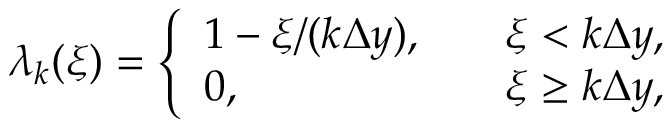Convert formula to latex. <formula><loc_0><loc_0><loc_500><loc_500>\lambda _ { k } ( \xi ) = \left \{ \begin{array} { l l } { 1 - \xi / ( k \Delta y ) , \quad } & { \xi < k \Delta y , } \\ { 0 , \quad } & { \xi \geq k \Delta y , } \end{array}</formula> 